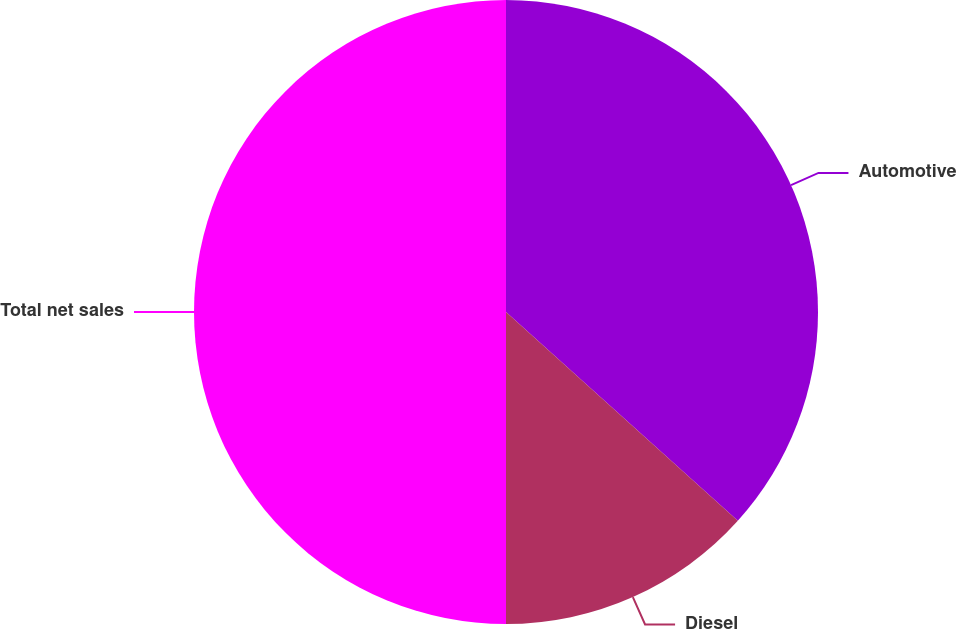Convert chart to OTSL. <chart><loc_0><loc_0><loc_500><loc_500><pie_chart><fcel>Automotive<fcel>Diesel<fcel>Total net sales<nl><fcel>36.67%<fcel>13.33%<fcel>50.0%<nl></chart> 